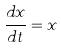<formula> <loc_0><loc_0><loc_500><loc_500>\frac { d x } { d t } = x</formula> 